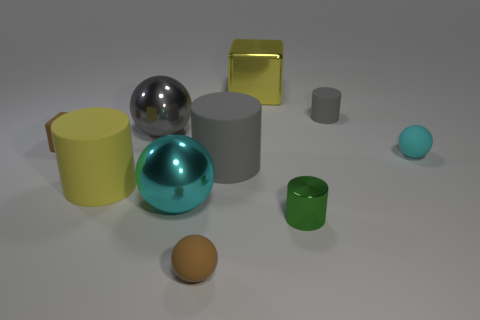What is the shape of the shiny object that is the same size as the cyan matte object?
Offer a terse response. Cylinder. What material is the brown ball?
Your answer should be compact. Rubber. What is the size of the ball that is behind the cyan rubber object on the right side of the gray rubber cylinder behind the big gray metal thing?
Give a very brief answer. Large. There is a thing that is the same color as the large cube; what material is it?
Offer a very short reply. Rubber. What number of matte objects are gray objects or blue blocks?
Provide a short and direct response. 2. The gray metallic thing is what size?
Give a very brief answer. Large. What number of objects are big blue shiny spheres or large shiny balls that are in front of the gray metallic thing?
Ensure brevity in your answer.  1. What number of other things are the same color as the small metallic thing?
Give a very brief answer. 0. There is a brown matte cube; is its size the same as the cylinder that is in front of the big yellow matte cylinder?
Make the answer very short. Yes. There is a brown object that is in front of the green thing; is its size the same as the matte block?
Provide a short and direct response. Yes. 